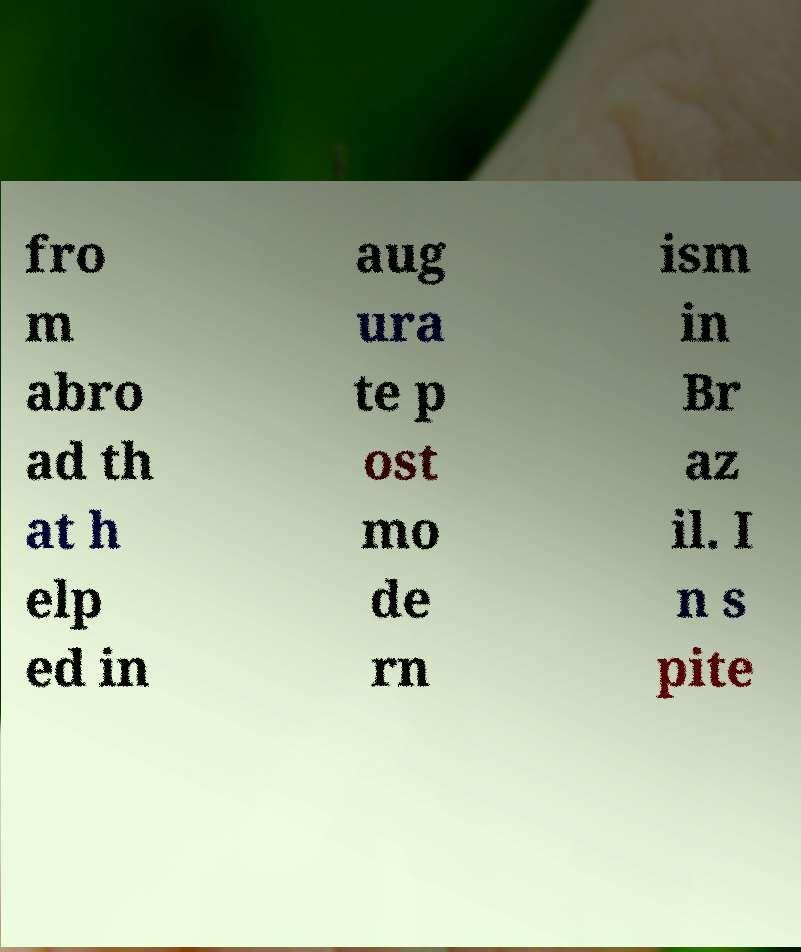Can you accurately transcribe the text from the provided image for me? fro m abro ad th at h elp ed in aug ura te p ost mo de rn ism in Br az il. I n s pite 